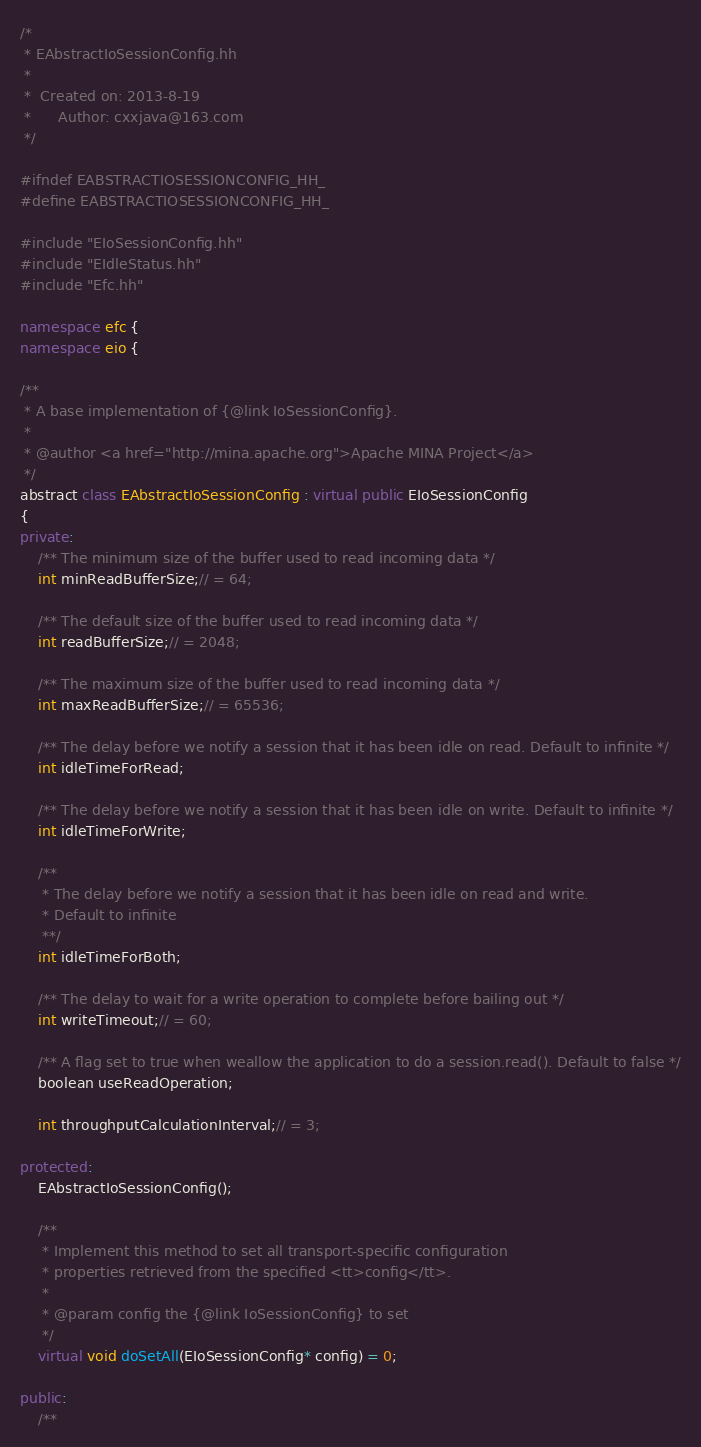Convert code to text. <code><loc_0><loc_0><loc_500><loc_500><_C++_>/*
 * EAbstractIoSessionConfig.hh
 *
 *  Created on: 2013-8-19
 *      Author: cxxjava@163.com
 */

#ifndef EABSTRACTIOSESSIONCONFIG_HH_
#define EABSTRACTIOSESSIONCONFIG_HH_

#include "EIoSessionConfig.hh"
#include "EIdleStatus.hh"
#include "Efc.hh"

namespace efc {
namespace eio {

/**
 * A base implementation of {@link IoSessionConfig}.
 *
 * @author <a href="http://mina.apache.org">Apache MINA Project</a>
 */
abstract class EAbstractIoSessionConfig : virtual public EIoSessionConfig
{
private:
	/** The minimum size of the buffer used to read incoming data */
    int minReadBufferSize;// = 64;

    /** The default size of the buffer used to read incoming data */
    int readBufferSize;// = 2048;

    /** The maximum size of the buffer used to read incoming data */
    int maxReadBufferSize;// = 65536;

    /** The delay before we notify a session that it has been idle on read. Default to infinite */
    int idleTimeForRead;

    /** The delay before we notify a session that it has been idle on write. Default to infinite */
    int idleTimeForWrite;

    /**
	 * The delay before we notify a session that it has been idle on read and write.
	 * Default to infinite
	 **/
    int idleTimeForBoth;

    /** The delay to wait for a write operation to complete before bailing out */
    int writeTimeout;// = 60;

    /** A flag set to true when weallow the application to do a session.read(). Default to false */
    boolean useReadOperation;

    int throughputCalculationInterval;// = 3;

protected:
	EAbstractIoSessionConfig();

	/**
     * Implement this method to set all transport-specific configuration
     * properties retrieved from the specified <tt>config</tt>.
     *
     * @param config the {@link IoSessionConfig} to set
     */
    virtual void doSetAll(EIoSessionConfig* config) = 0;
    
public:
    /**</code> 